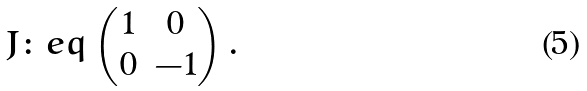Convert formula to latex. <formula><loc_0><loc_0><loc_500><loc_500>J & \colon e q \begin{pmatrix} 1 & 0 \\ 0 & - 1 \end{pmatrix} .</formula> 